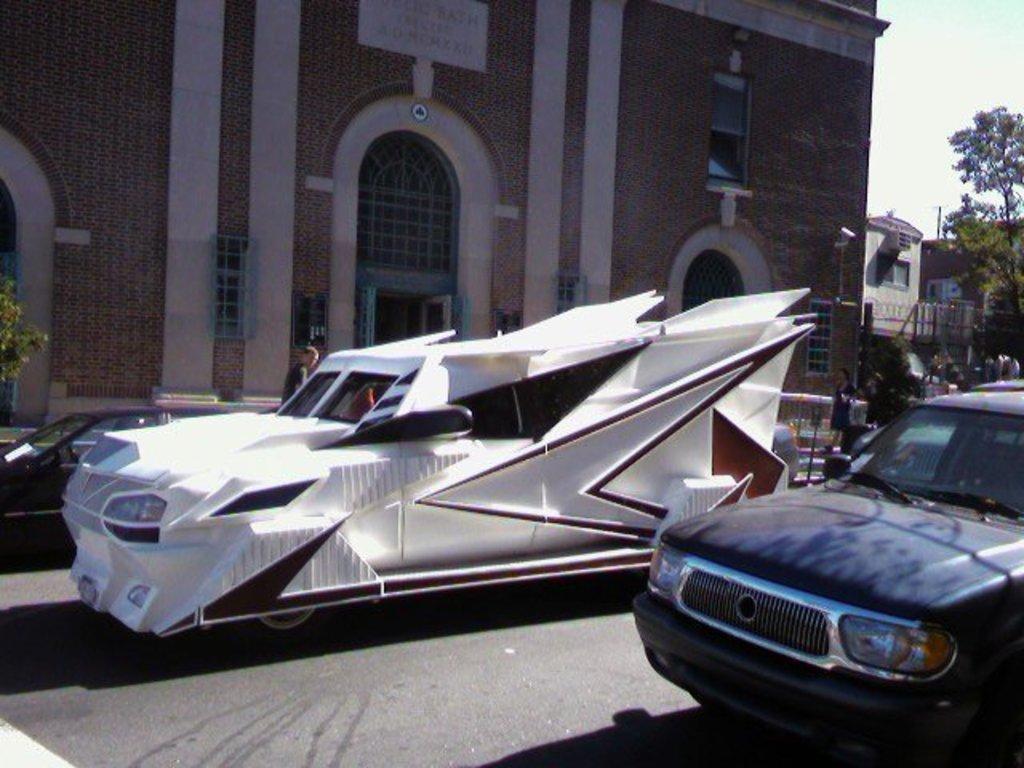Could you give a brief overview of what you see in this image? In the foreground of the image we can see vehicles parked on the ground. In the center of the image we can see people standing. In the background, we can see buildings with windows, trees, board with some text and the sky. 